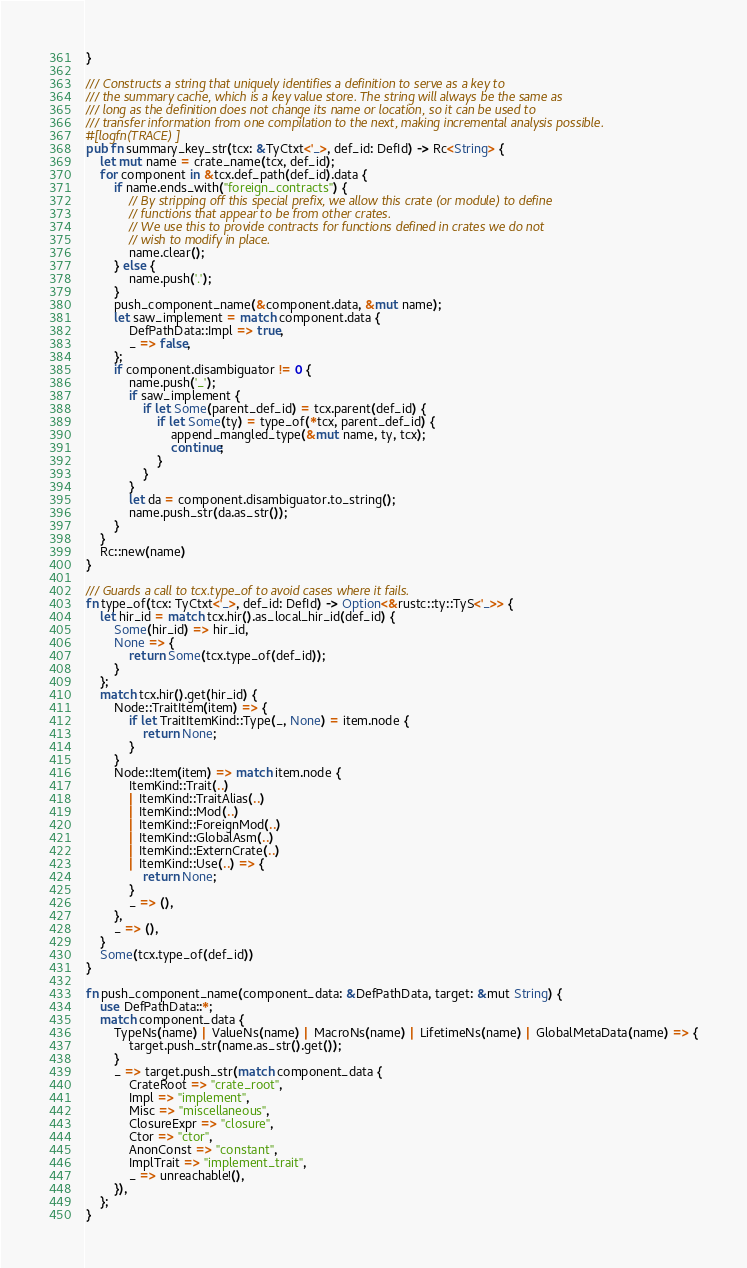Convert code to text. <code><loc_0><loc_0><loc_500><loc_500><_Rust_>}

/// Constructs a string that uniquely identifies a definition to serve as a key to
/// the summary cache, which is a key value store. The string will always be the same as
/// long as the definition does not change its name or location, so it can be used to
/// transfer information from one compilation to the next, making incremental analysis possible.
#[logfn(TRACE)]
pub fn summary_key_str(tcx: &TyCtxt<'_>, def_id: DefId) -> Rc<String> {
    let mut name = crate_name(tcx, def_id);
    for component in &tcx.def_path(def_id).data {
        if name.ends_with("foreign_contracts") {
            // By stripping off this special prefix, we allow this crate (or module) to define
            // functions that appear to be from other crates.
            // We use this to provide contracts for functions defined in crates we do not
            // wish to modify in place.
            name.clear();
        } else {
            name.push('.');
        }
        push_component_name(&component.data, &mut name);
        let saw_implement = match component.data {
            DefPathData::Impl => true,
            _ => false,
        };
        if component.disambiguator != 0 {
            name.push('_');
            if saw_implement {
                if let Some(parent_def_id) = tcx.parent(def_id) {
                    if let Some(ty) = type_of(*tcx, parent_def_id) {
                        append_mangled_type(&mut name, ty, tcx);
                        continue;
                    }
                }
            }
            let da = component.disambiguator.to_string();
            name.push_str(da.as_str());
        }
    }
    Rc::new(name)
}

/// Guards a call to tcx.type_of to avoid cases where it fails.
fn type_of(tcx: TyCtxt<'_>, def_id: DefId) -> Option<&rustc::ty::TyS<'_>> {
    let hir_id = match tcx.hir().as_local_hir_id(def_id) {
        Some(hir_id) => hir_id,
        None => {
            return Some(tcx.type_of(def_id));
        }
    };
    match tcx.hir().get(hir_id) {
        Node::TraitItem(item) => {
            if let TraitItemKind::Type(_, None) = item.node {
                return None;
            }
        }
        Node::Item(item) => match item.node {
            ItemKind::Trait(..)
            | ItemKind::TraitAlias(..)
            | ItemKind::Mod(..)
            | ItemKind::ForeignMod(..)
            | ItemKind::GlobalAsm(..)
            | ItemKind::ExternCrate(..)
            | ItemKind::Use(..) => {
                return None;
            }
            _ => (),
        },
        _ => (),
    }
    Some(tcx.type_of(def_id))
}

fn push_component_name(component_data: &DefPathData, target: &mut String) {
    use DefPathData::*;
    match component_data {
        TypeNs(name) | ValueNs(name) | MacroNs(name) | LifetimeNs(name) | GlobalMetaData(name) => {
            target.push_str(name.as_str().get());
        }
        _ => target.push_str(match component_data {
            CrateRoot => "crate_root",
            Impl => "implement",
            Misc => "miscellaneous",
            ClosureExpr => "closure",
            Ctor => "ctor",
            AnonConst => "constant",
            ImplTrait => "implement_trait",
            _ => unreachable!(),
        }),
    };
}
</code> 